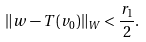Convert formula to latex. <formula><loc_0><loc_0><loc_500><loc_500>\| w - T ( v _ { 0 } ) \| _ { W } < \frac { r _ { 1 } } { 2 } .</formula> 